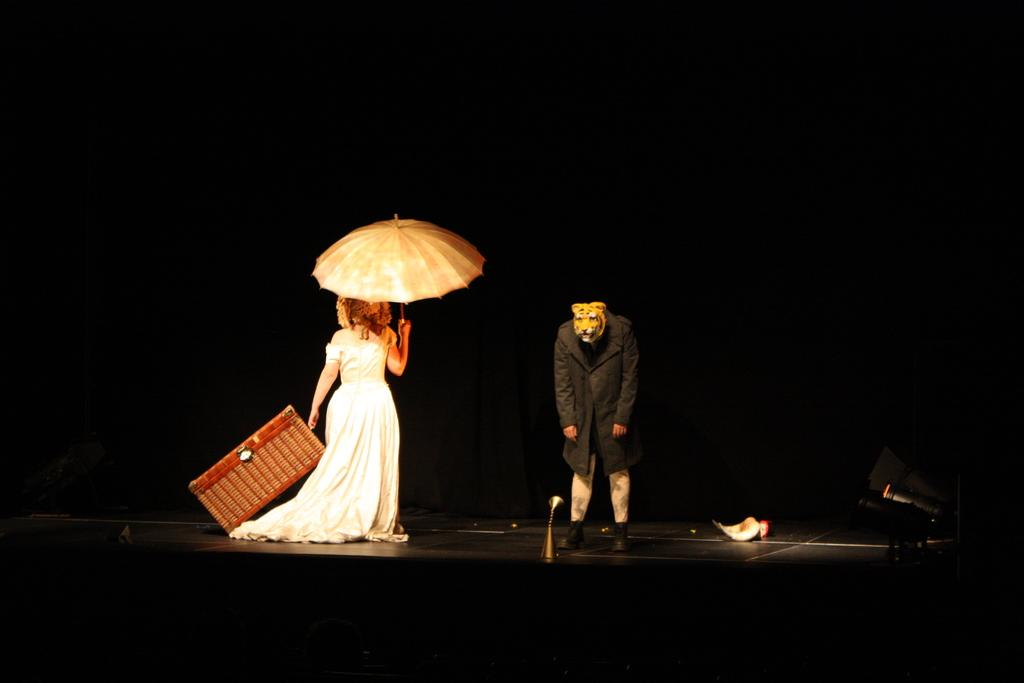Who is the main subject in the image? There is a lady in the image. What is the lady holding in the image? The lady is holding an umbrella. Where is the lady standing in the image? The lady is standing on a dais. Can you describe the person wearing a mask in the image? There is a person in the image wearing a mask of a tiger. What type of appliance is being used by the lady in the image? There is no appliance being used by the lady in the image. 